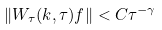<formula> <loc_0><loc_0><loc_500><loc_500>\| W _ { \tau } ( k , \tau ) f \| < C \tau ^ { - \gamma }</formula> 